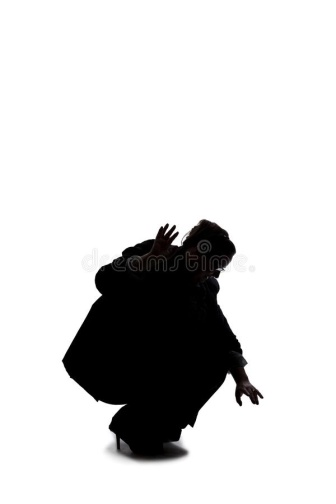How would you relate this image to a scene from nature? This image could be related to a scene from nature where a predator, such as a big cat, is preparing to pounce on its prey. The crouched posture and focus on readiness reflect an animal in the wild, low to the ground to stay hidden, muscles coiled in anticipation of making the swift, decisive move to ensure a successful hunt. The starkness of the white background parallels the open space of a plain or savannah, enhancing the sense of isolation and the raw, primal moment before the action unfolds. How might this image integrate into a philosophical discussion? This image could integrate into a philosophical discussion around the concepts of existentialism and the human condition. The solitary figure, poised in an uncertain state, embodies the essence of existential angst and the struggle for meaning in an indifferent universe. The stark, empty background could symbolize the existential void, a blank slate that highlights the individual's confrontation with the unknown and the quest for purpose. The readiness to act despite the emptiness around them could reflect a philosophical stance that emphasizes individual agency, resilience, and the human spirit's determination to create meaning even in the face of potential absurdity. 